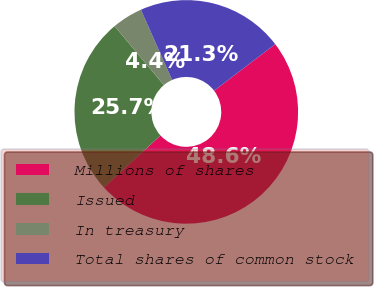<chart> <loc_0><loc_0><loc_500><loc_500><pie_chart><fcel>Millions of shares<fcel>Issued<fcel>In treasury<fcel>Total shares of common stock<nl><fcel>48.56%<fcel>25.72%<fcel>4.43%<fcel>21.29%<nl></chart> 